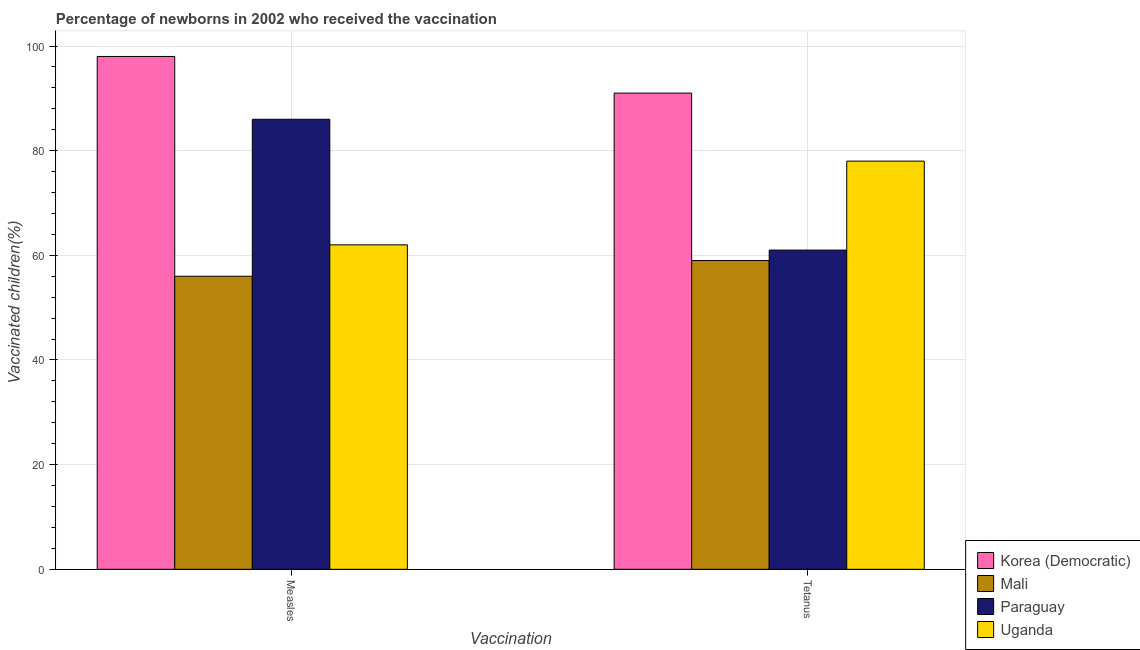How many different coloured bars are there?
Offer a terse response. 4. How many groups of bars are there?
Make the answer very short. 2. Are the number of bars on each tick of the X-axis equal?
Ensure brevity in your answer.  Yes. How many bars are there on the 1st tick from the left?
Provide a short and direct response. 4. How many bars are there on the 2nd tick from the right?
Offer a very short reply. 4. What is the label of the 1st group of bars from the left?
Provide a succinct answer. Measles. What is the percentage of newborns who received vaccination for tetanus in Paraguay?
Your answer should be compact. 61. Across all countries, what is the maximum percentage of newborns who received vaccination for measles?
Provide a short and direct response. 98. Across all countries, what is the minimum percentage of newborns who received vaccination for tetanus?
Your answer should be compact. 59. In which country was the percentage of newborns who received vaccination for tetanus maximum?
Offer a very short reply. Korea (Democratic). In which country was the percentage of newborns who received vaccination for measles minimum?
Your answer should be compact. Mali. What is the total percentage of newborns who received vaccination for tetanus in the graph?
Offer a terse response. 289. What is the difference between the percentage of newborns who received vaccination for measles in Mali and that in Paraguay?
Give a very brief answer. -30. What is the difference between the percentage of newborns who received vaccination for measles in Uganda and the percentage of newborns who received vaccination for tetanus in Paraguay?
Provide a succinct answer. 1. What is the average percentage of newborns who received vaccination for measles per country?
Keep it short and to the point. 75.5. What is the difference between the percentage of newborns who received vaccination for measles and percentage of newborns who received vaccination for tetanus in Uganda?
Make the answer very short. -16. In how many countries, is the percentage of newborns who received vaccination for measles greater than 40 %?
Your answer should be very brief. 4. What is the ratio of the percentage of newborns who received vaccination for measles in Paraguay to that in Mali?
Your answer should be very brief. 1.54. What does the 3rd bar from the left in Measles represents?
Your answer should be compact. Paraguay. What does the 2nd bar from the right in Measles represents?
Make the answer very short. Paraguay. How many countries are there in the graph?
Ensure brevity in your answer.  4. What is the difference between two consecutive major ticks on the Y-axis?
Your response must be concise. 20. Are the values on the major ticks of Y-axis written in scientific E-notation?
Make the answer very short. No. Does the graph contain any zero values?
Your response must be concise. No. Does the graph contain grids?
Ensure brevity in your answer.  Yes. Where does the legend appear in the graph?
Your answer should be very brief. Bottom right. What is the title of the graph?
Keep it short and to the point. Percentage of newborns in 2002 who received the vaccination. Does "Moldova" appear as one of the legend labels in the graph?
Your answer should be very brief. No. What is the label or title of the X-axis?
Provide a succinct answer. Vaccination. What is the label or title of the Y-axis?
Make the answer very short. Vaccinated children(%)
. What is the Vaccinated children(%)
 of Mali in Measles?
Your answer should be very brief. 56. What is the Vaccinated children(%)
 of Uganda in Measles?
Your answer should be compact. 62. What is the Vaccinated children(%)
 in Korea (Democratic) in Tetanus?
Make the answer very short. 91. What is the Vaccinated children(%)
 of Mali in Tetanus?
Your answer should be very brief. 59. Across all Vaccination, what is the maximum Vaccinated children(%)
 of Korea (Democratic)?
Provide a short and direct response. 98. Across all Vaccination, what is the minimum Vaccinated children(%)
 in Korea (Democratic)?
Provide a short and direct response. 91. Across all Vaccination, what is the minimum Vaccinated children(%)
 in Mali?
Make the answer very short. 56. Across all Vaccination, what is the minimum Vaccinated children(%)
 in Uganda?
Keep it short and to the point. 62. What is the total Vaccinated children(%)
 in Korea (Democratic) in the graph?
Ensure brevity in your answer.  189. What is the total Vaccinated children(%)
 in Mali in the graph?
Provide a succinct answer. 115. What is the total Vaccinated children(%)
 in Paraguay in the graph?
Offer a very short reply. 147. What is the total Vaccinated children(%)
 in Uganda in the graph?
Ensure brevity in your answer.  140. What is the difference between the Vaccinated children(%)
 in Mali in Measles and that in Tetanus?
Your answer should be compact. -3. What is the difference between the Vaccinated children(%)
 of Paraguay in Measles and that in Tetanus?
Your response must be concise. 25. What is the difference between the Vaccinated children(%)
 in Uganda in Measles and that in Tetanus?
Make the answer very short. -16. What is the difference between the Vaccinated children(%)
 in Korea (Democratic) in Measles and the Vaccinated children(%)
 in Mali in Tetanus?
Your response must be concise. 39. What is the difference between the Vaccinated children(%)
 in Korea (Democratic) in Measles and the Vaccinated children(%)
 in Paraguay in Tetanus?
Provide a short and direct response. 37. What is the difference between the Vaccinated children(%)
 of Korea (Democratic) in Measles and the Vaccinated children(%)
 of Uganda in Tetanus?
Offer a terse response. 20. What is the difference between the Vaccinated children(%)
 in Mali in Measles and the Vaccinated children(%)
 in Paraguay in Tetanus?
Your answer should be very brief. -5. What is the difference between the Vaccinated children(%)
 in Paraguay in Measles and the Vaccinated children(%)
 in Uganda in Tetanus?
Provide a short and direct response. 8. What is the average Vaccinated children(%)
 of Korea (Democratic) per Vaccination?
Your response must be concise. 94.5. What is the average Vaccinated children(%)
 of Mali per Vaccination?
Provide a short and direct response. 57.5. What is the average Vaccinated children(%)
 in Paraguay per Vaccination?
Your answer should be very brief. 73.5. What is the difference between the Vaccinated children(%)
 in Mali and Vaccinated children(%)
 in Paraguay in Measles?
Your answer should be very brief. -30. What is the difference between the Vaccinated children(%)
 of Paraguay and Vaccinated children(%)
 of Uganda in Measles?
Your answer should be very brief. 24. What is the difference between the Vaccinated children(%)
 in Korea (Democratic) and Vaccinated children(%)
 in Mali in Tetanus?
Keep it short and to the point. 32. What is the difference between the Vaccinated children(%)
 of Korea (Democratic) and Vaccinated children(%)
 of Paraguay in Tetanus?
Offer a terse response. 30. What is the difference between the Vaccinated children(%)
 in Mali and Vaccinated children(%)
 in Paraguay in Tetanus?
Ensure brevity in your answer.  -2. What is the difference between the Vaccinated children(%)
 in Paraguay and Vaccinated children(%)
 in Uganda in Tetanus?
Ensure brevity in your answer.  -17. What is the ratio of the Vaccinated children(%)
 in Mali in Measles to that in Tetanus?
Offer a very short reply. 0.95. What is the ratio of the Vaccinated children(%)
 in Paraguay in Measles to that in Tetanus?
Your answer should be compact. 1.41. What is the ratio of the Vaccinated children(%)
 in Uganda in Measles to that in Tetanus?
Give a very brief answer. 0.79. What is the difference between the highest and the second highest Vaccinated children(%)
 in Korea (Democratic)?
Offer a terse response. 7. What is the difference between the highest and the second highest Vaccinated children(%)
 in Mali?
Offer a very short reply. 3. What is the difference between the highest and the second highest Vaccinated children(%)
 in Uganda?
Make the answer very short. 16. What is the difference between the highest and the lowest Vaccinated children(%)
 of Korea (Democratic)?
Provide a short and direct response. 7. What is the difference between the highest and the lowest Vaccinated children(%)
 in Mali?
Provide a short and direct response. 3. What is the difference between the highest and the lowest Vaccinated children(%)
 of Uganda?
Offer a very short reply. 16. 